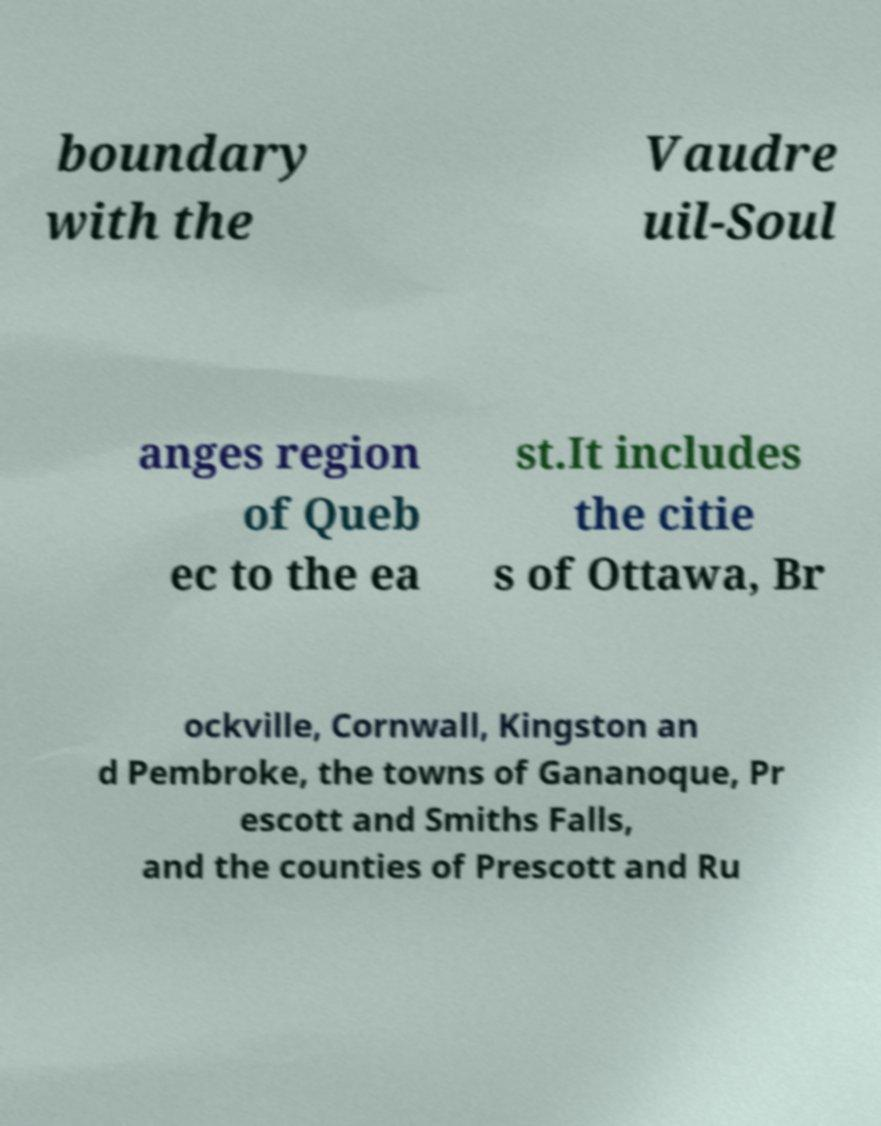Please identify and transcribe the text found in this image. boundary with the Vaudre uil-Soul anges region of Queb ec to the ea st.It includes the citie s of Ottawa, Br ockville, Cornwall, Kingston an d Pembroke, the towns of Gananoque, Pr escott and Smiths Falls, and the counties of Prescott and Ru 